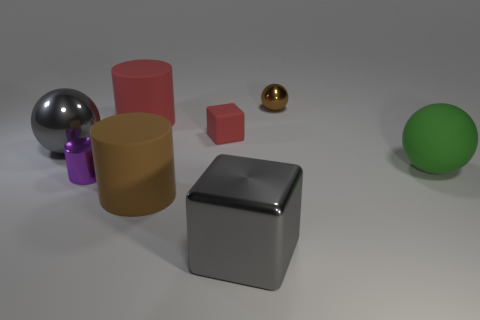Add 2 large blue rubber objects. How many objects exist? 10 Subtract all balls. How many objects are left? 5 Subtract all small green rubber objects. Subtract all big red matte cylinders. How many objects are left? 7 Add 4 gray metallic spheres. How many gray metallic spheres are left? 5 Add 8 brown things. How many brown things exist? 10 Subtract 0 cyan spheres. How many objects are left? 8 